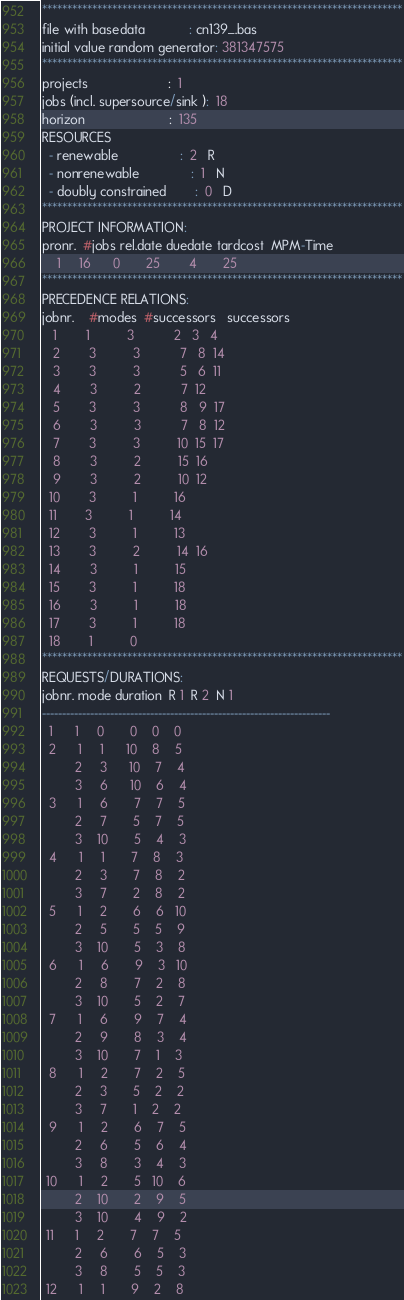Convert code to text. <code><loc_0><loc_0><loc_500><loc_500><_ObjectiveC_>************************************************************************
file with basedata            : cn139_.bas
initial value random generator: 381347575
************************************************************************
projects                      :  1
jobs (incl. supersource/sink ):  18
horizon                       :  135
RESOURCES
  - renewable                 :  2   R
  - nonrenewable              :  1   N
  - doubly constrained        :  0   D
************************************************************************
PROJECT INFORMATION:
pronr.  #jobs rel.date duedate tardcost  MPM-Time
    1     16      0       25        4       25
************************************************************************
PRECEDENCE RELATIONS:
jobnr.    #modes  #successors   successors
   1        1          3           2   3   4
   2        3          3           7   8  14
   3        3          3           5   6  11
   4        3          2           7  12
   5        3          3           8   9  17
   6        3          3           7   8  12
   7        3          3          10  15  17
   8        3          2          15  16
   9        3          2          10  12
  10        3          1          16
  11        3          1          14
  12        3          1          13
  13        3          2          14  16
  14        3          1          15
  15        3          1          18
  16        3          1          18
  17        3          1          18
  18        1          0        
************************************************************************
REQUESTS/DURATIONS:
jobnr. mode duration  R 1  R 2  N 1
------------------------------------------------------------------------
  1      1     0       0    0    0
  2      1     1      10    8    5
         2     3      10    7    4
         3     6      10    6    4
  3      1     6       7    7    5
         2     7       5    7    5
         3    10       5    4    3
  4      1     1       7    8    3
         2     3       7    8    2
         3     7       2    8    2
  5      1     2       6    6   10
         2     5       5    5    9
         3    10       5    3    8
  6      1     6       9    3   10
         2     8       7    2    8
         3    10       5    2    7
  7      1     6       9    7    4
         2     9       8    3    4
         3    10       7    1    3
  8      1     2       7    2    5
         2     3       5    2    2
         3     7       1    2    2
  9      1     2       6    7    5
         2     6       5    6    4
         3     8       3    4    3
 10      1     2       5   10    6
         2    10       2    9    5
         3    10       4    9    2
 11      1     2       7    7    5
         2     6       6    5    3
         3     8       5    5    3
 12      1     1       9    2    8</code> 